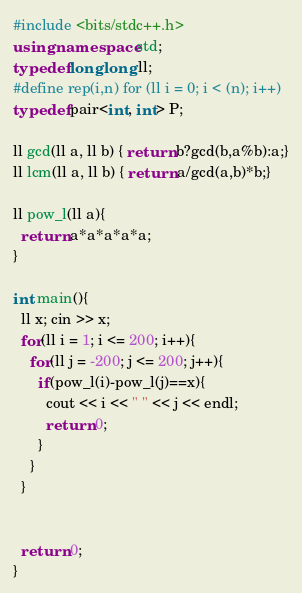<code> <loc_0><loc_0><loc_500><loc_500><_C++_>#include <bits/stdc++.h>
using namespace std;
typedef long long ll;
#define rep(i,n) for (ll i = 0; i < (n); i++)
typedef pair<int, int> P;

ll gcd(ll a, ll b) { return b?gcd(b,a%b):a;}
ll lcm(ll a, ll b) { return a/gcd(a,b)*b;}

ll pow_l(ll a){
  return a*a*a*a*a;
}

int main(){
  ll x; cin >> x;
  for(ll i = 1; i <= 200; i++){
    for(ll j = -200; j <= 200; j++){
      if(pow_l(i)-pow_l(j)==x){
        cout << i << " " << j << endl;
        return 0;
      }
    }
  }

  
  return 0;
}</code> 